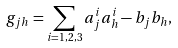Convert formula to latex. <formula><loc_0><loc_0><loc_500><loc_500>g _ { j h } = \sum _ { i = 1 , 2 , 3 } a _ { j } ^ { i } a _ { h } ^ { i } - b _ { j } b _ { h } ,</formula> 